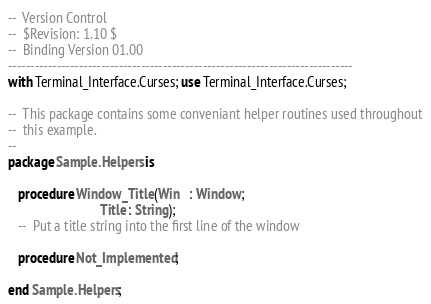Convert code to text. <code><loc_0><loc_0><loc_500><loc_500><_Ada_>--  Version Control
--  $Revision: 1.10 $
--  Binding Version 01.00
------------------------------------------------------------------------------
with Terminal_Interface.Curses; use Terminal_Interface.Curses;

--  This package contains some conveniant helper routines used throughout
--  this example.
--
package Sample.Helpers is

   procedure Window_Title (Win   : Window;
                           Title : String);
   --  Put a title string into the first line of the window

   procedure Not_Implemented;

end Sample.Helpers;
</code> 